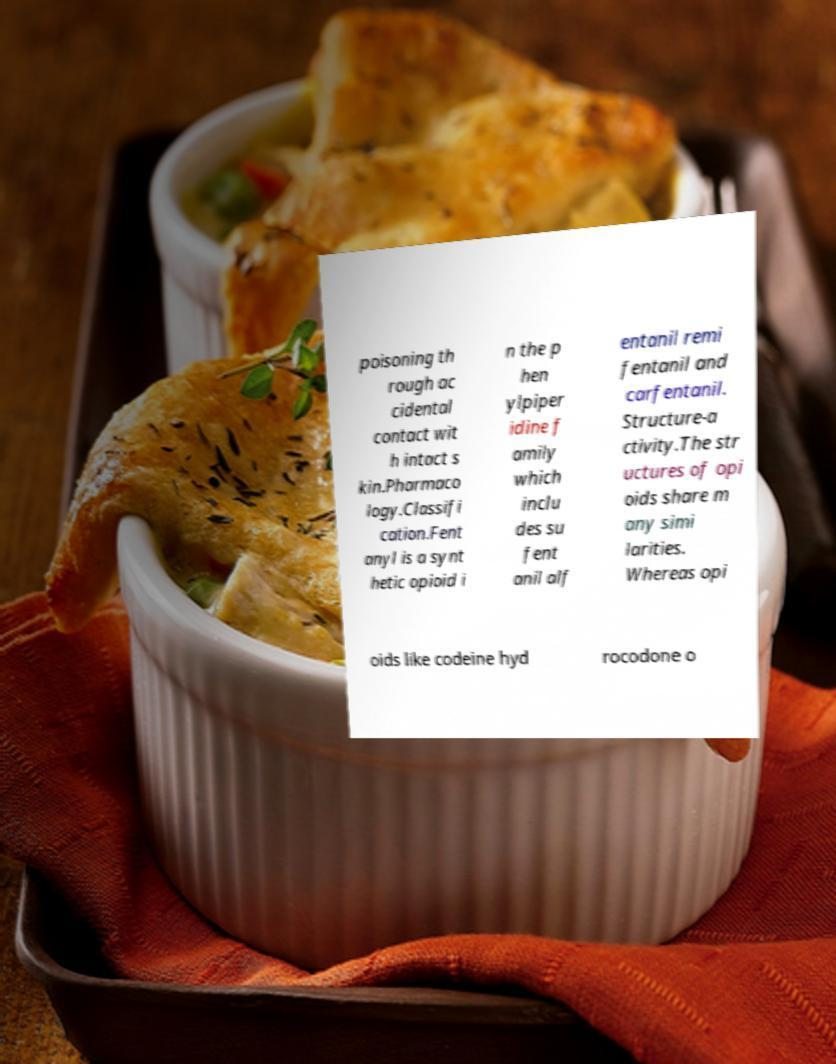Could you extract and type out the text from this image? poisoning th rough ac cidental contact wit h intact s kin.Pharmaco logy.Classifi cation.Fent anyl is a synt hetic opioid i n the p hen ylpiper idine f amily which inclu des su fent anil alf entanil remi fentanil and carfentanil. Structure-a ctivity.The str uctures of opi oids share m any simi larities. Whereas opi oids like codeine hyd rocodone o 